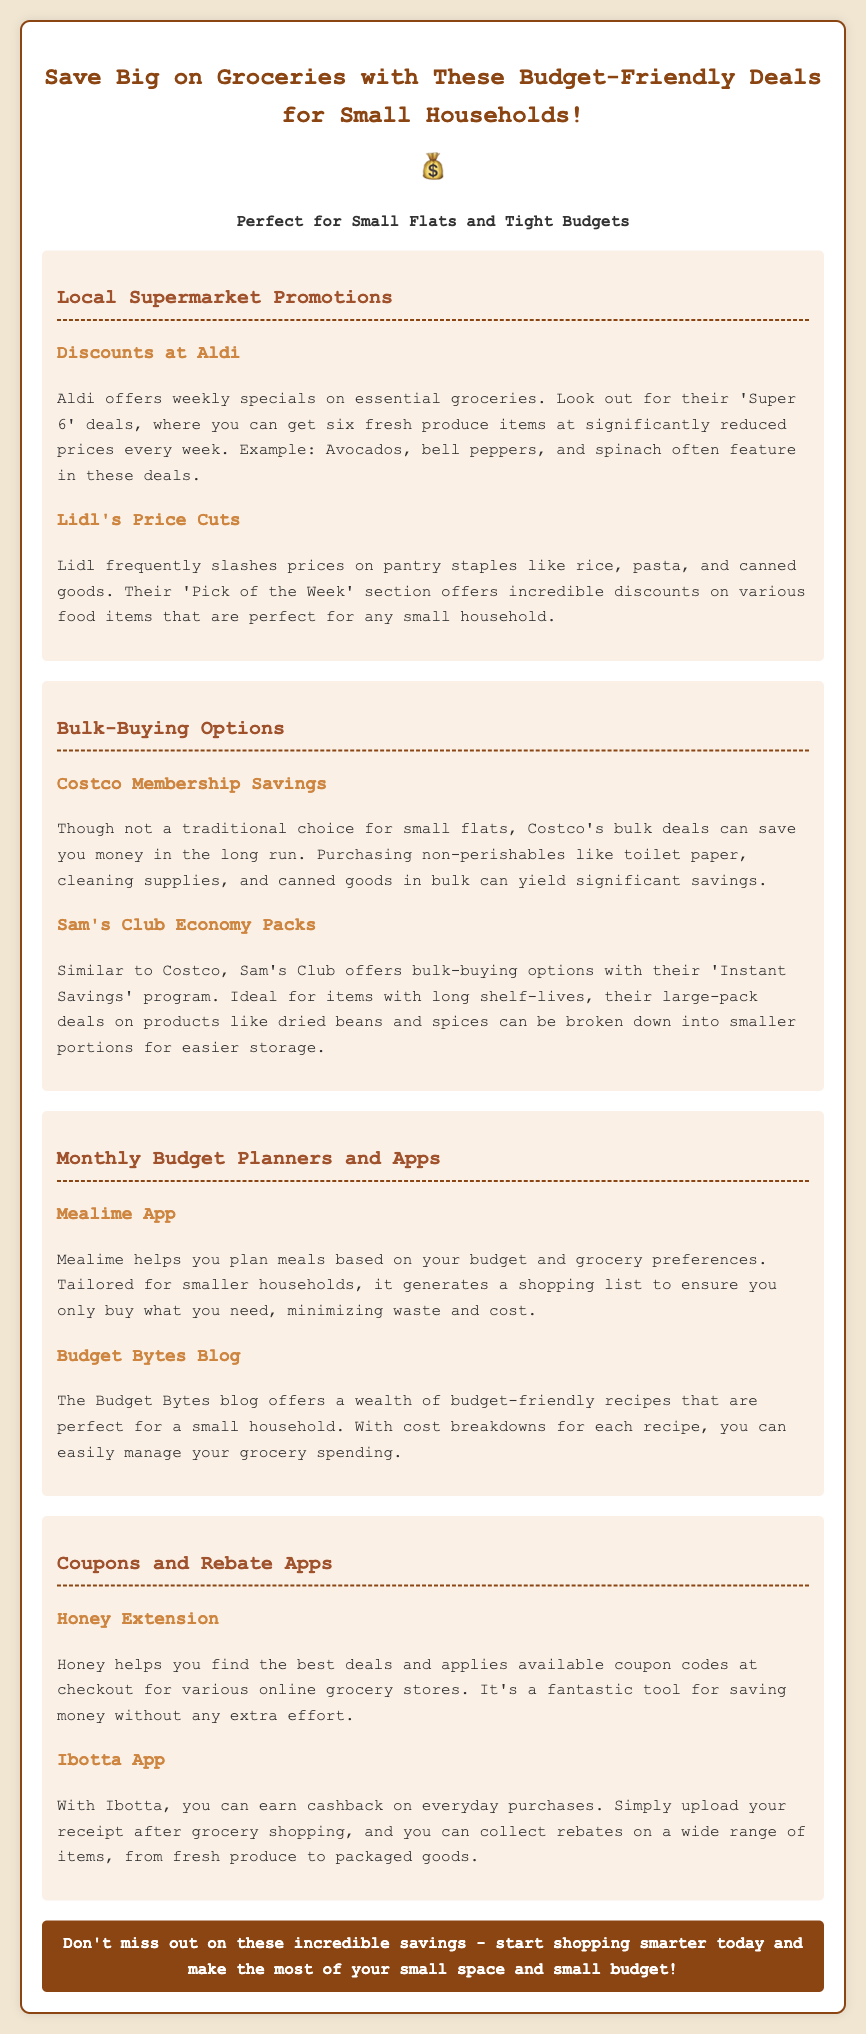what is the title of the document? The title of the document is explicitly stated in the HTML head section, which is “Budget-Friendly Grocery Deals for Small Households.”
Answer: Budget-Friendly Grocery Deals for Small Households what is one weekly special offered by Aldi? The document mentions the 'Super 6' deals at Aldi, where you can buy six fresh produce items at reduced prices.
Answer: Super 6 what kind of app is Mealime? The document describes Mealime as an app that helps plan meals based on budget and grocery preferences.
Answer: Meal planning app which grocery store is mentioned for bulk-buying options? The document lists Costco and Sam's Club as stores that offer bulk-buying options for groceries.
Answer: Costco how can you earn cashback with Ibotta? According to the document, you can earn cashback by uploading your receipt after grocery shopping.
Answer: Uploading receipt what type of items does Lidl frequently discount? Lidl frequently discounts pantry staples like rice, pasta, and canned goods.
Answer: Pantry staples what is the purpose of the Honey Extension? The Honey Extension helps find the best deals and applies coupon codes at checkout in online grocery stores.
Answer: Finding deals what kind of discounts does Sam's Club offer? Sam's Club offers bulk-buying options with the 'Instant Savings' program.
Answer: Instant Savings what is the main focus of Budget Bytes Blog? The Budget Bytes Blog focuses on budget-friendly recipes suitable for small households.
Answer: Budget-friendly recipes 